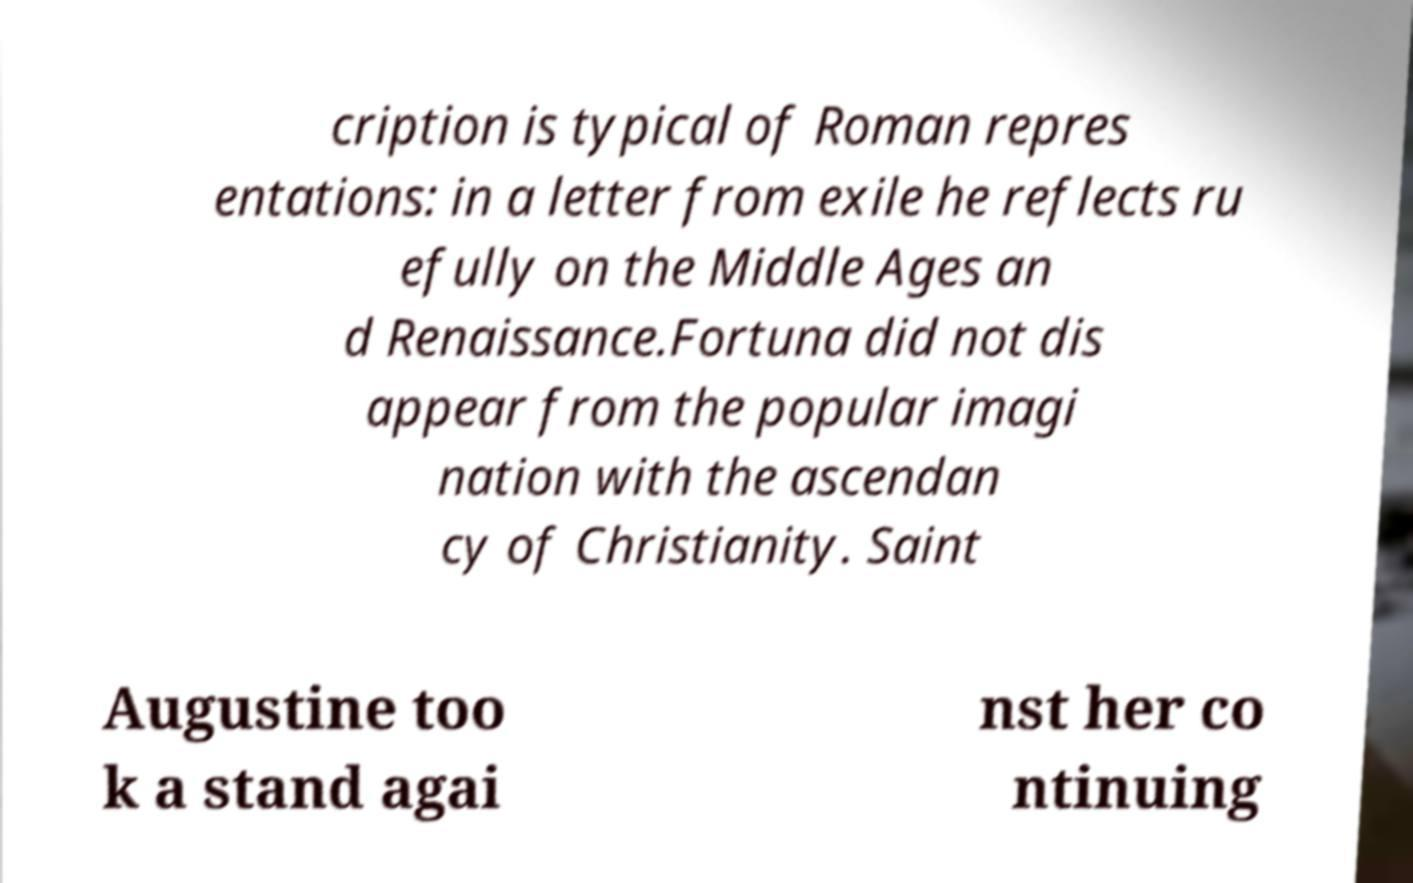Could you assist in decoding the text presented in this image and type it out clearly? cription is typical of Roman repres entations: in a letter from exile he reflects ru efully on the Middle Ages an d Renaissance.Fortuna did not dis appear from the popular imagi nation with the ascendan cy of Christianity. Saint Augustine too k a stand agai nst her co ntinuing 